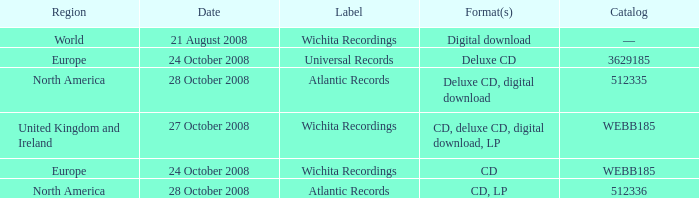Which formats have a region of Europe and Catalog value of WEBB185? CD. 